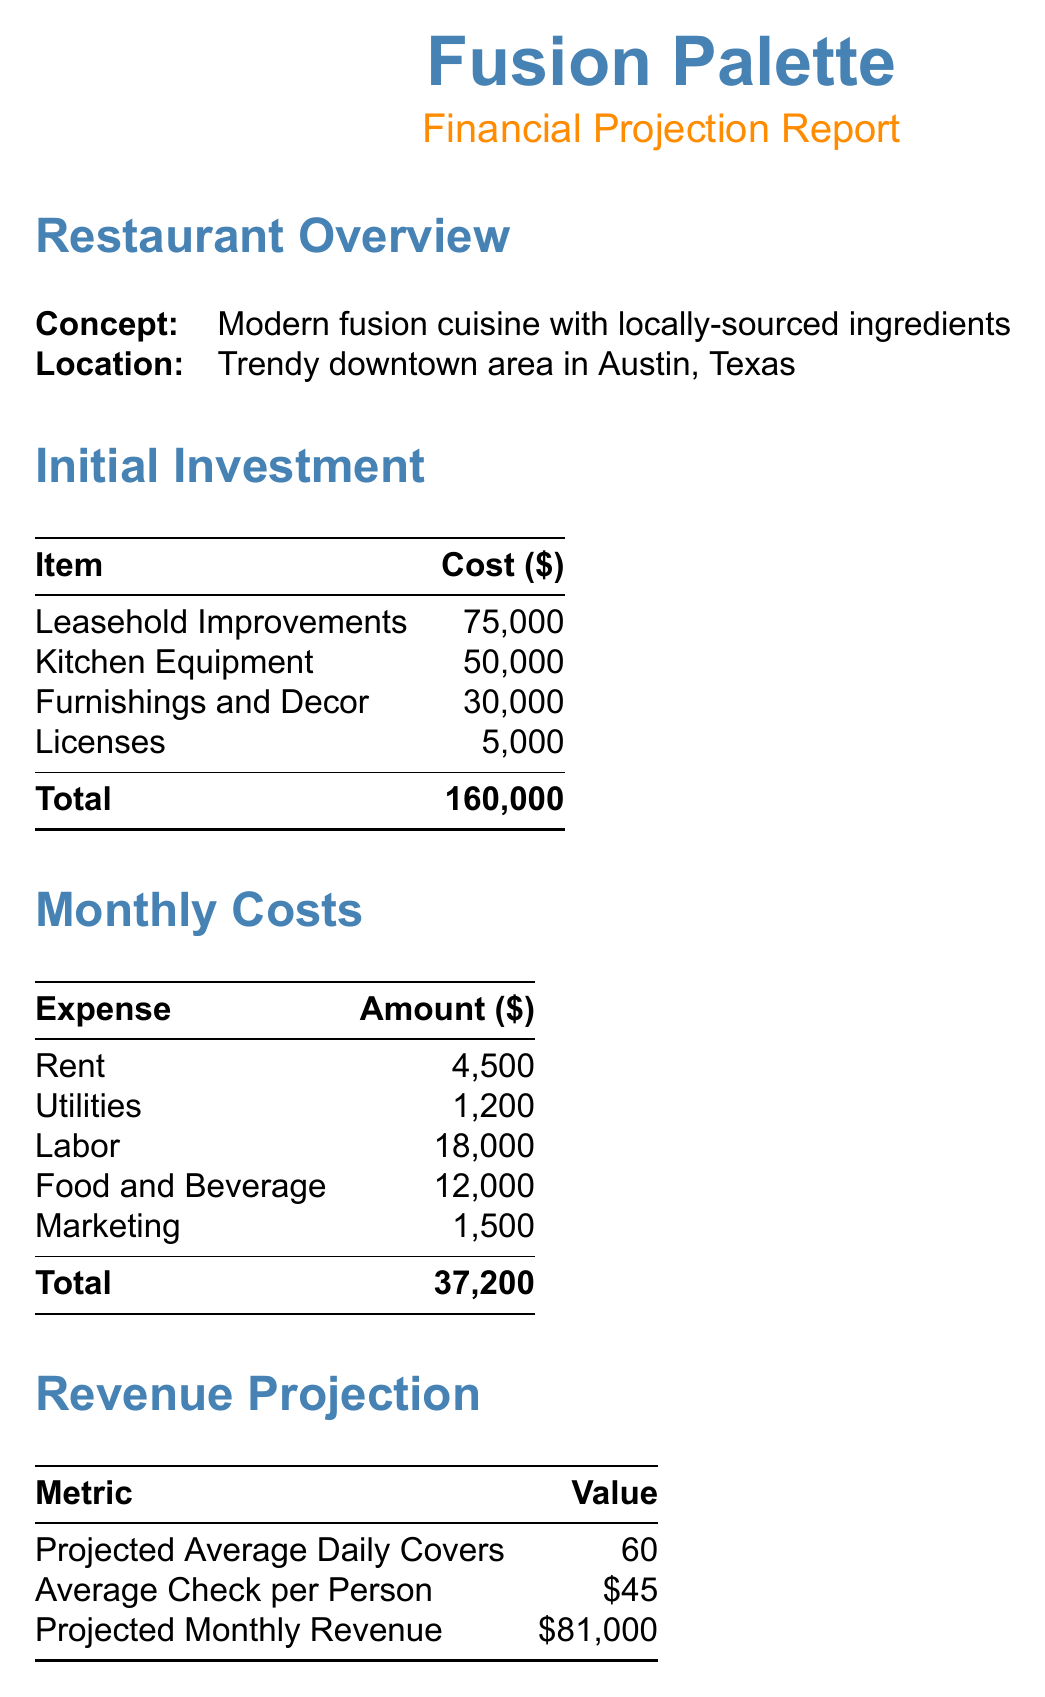What is the name of the restaurant? The restaurant name is stated at the beginning of the document.
Answer: Fusion Palette What is the concept of the restaurant? The concept is described in the restaurant overview section.
Answer: Modern fusion cuisine with locally-sourced ingredients What is the total initial investment? The total initial investment is the sum of all the costs listed in the initial investment section.
Answer: 160,000 What are the monthly labor costs? Labor costs are specifically mentioned in the monthly costs section.
Answer: 18,000 What is the projected monthly revenue? The projected monthly revenue is calculated and stated in the revenue projection section.
Answer: 81,000 What is the break-even point (monthly)? The break-even point is listed in the financial analysis section of the document.
Answer: 42,000 How long is the estimated return on investment? This information is provided in the financial analysis section.
Answer: 24 months What is the average check per person? The average check per person is mentioned in the revenue projection section of the document.
Answer: 45 What is the total amount of personal savings used for funding? The amount of personal savings is specifically stated under the funding sources section.
Answer: 50,000 